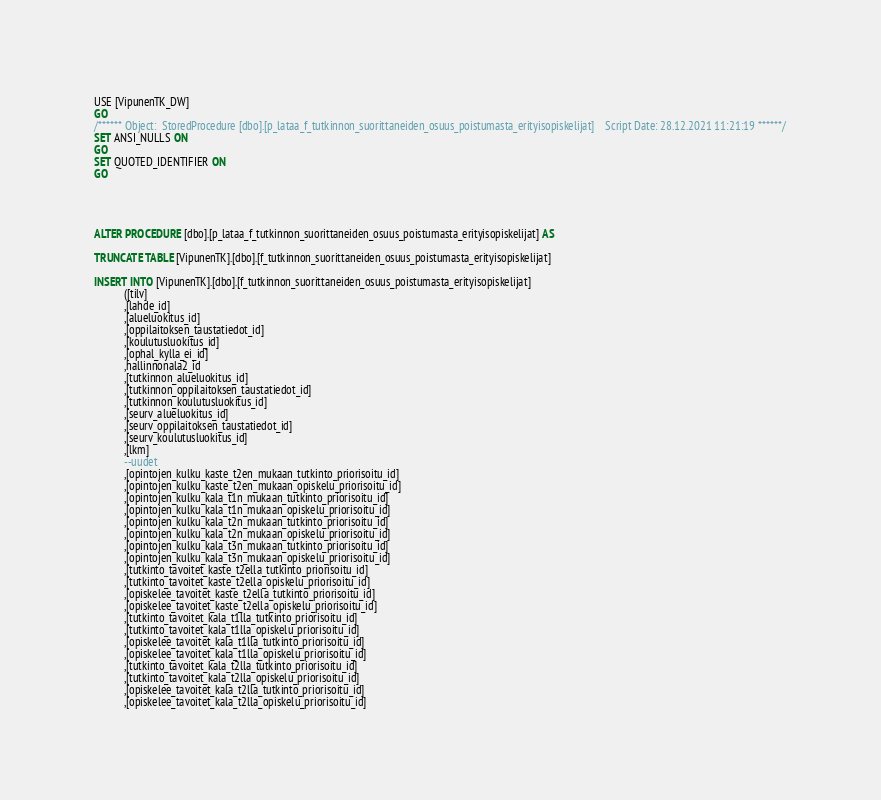<code> <loc_0><loc_0><loc_500><loc_500><_SQL_>USE [VipunenTK_DW]
GO
/****** Object:  StoredProcedure [dbo].[p_lataa_f_tutkinnon_suorittaneiden_osuus_poistumasta_erityisopiskelijat]    Script Date: 28.12.2021 11:21:19 ******/
SET ANSI_NULLS ON
GO
SET QUOTED_IDENTIFIER ON
GO




ALTER PROCEDURE [dbo].[p_lataa_f_tutkinnon_suorittaneiden_osuus_poistumasta_erityisopiskelijat] AS

TRUNCATE TABLE [VipunenTK].[dbo].[f_tutkinnon_suorittaneiden_osuus_poistumasta_erityisopiskelijat]

INSERT INTO [VipunenTK].[dbo].[f_tutkinnon_suorittaneiden_osuus_poistumasta_erityisopiskelijat]
           ([tilv]
           ,[lahde_id]
           ,[alueluokitus_id]
           ,[oppilaitoksen_taustatiedot_id]
           ,[koulutusluokitus_id]
           ,[ophal_kylla_ei_id]
		   ,hallinnonala2_id
           ,[tutkinnon_alueluokitus_id]
           ,[tutkinnon_oppilaitoksen_taustatiedot_id]
           ,[tutkinnon_koulutusluokitus_id]
           ,[seurv_alueluokitus_id]
           ,[seurv_oppilaitoksen_taustatiedot_id]
           ,[seurv_koulutusluokitus_id]
           ,[lkm]
		   --uudet
           ,[opintojen_kulku_kaste_t2en_mukaan_tutkinto_priorisoitu_id]
           ,[opintojen_kulku_kaste_t2en_mukaan_opiskelu_priorisoitu_id]
           ,[opintojen_kulku_kala_t1n_mukaan_tutkinto_priorisoitu_id]
           ,[opintojen_kulku_kala_t1n_mukaan_opiskelu_priorisoitu_id]
           ,[opintojen_kulku_kala_t2n_mukaan_tutkinto_priorisoitu_id]
           ,[opintojen_kulku_kala_t2n_mukaan_opiskelu_priorisoitu_id]
           ,[opintojen_kulku_kala_t3n_mukaan_tutkinto_priorisoitu_id]
           ,[opintojen_kulku_kala_t3n_mukaan_opiskelu_priorisoitu_id]
           ,[tutkinto_tavoitet_kaste_t2ella_tutkinto_priorisoitu_id]
           ,[tutkinto_tavoitet_kaste_t2ella_opiskelu_priorisoitu_id]
           ,[opiskelee_tavoitet_kaste_t2ella_tutkinto_priorisoitu_id]
           ,[opiskelee_tavoitet_kaste_t2ella_opiskelu_priorisoitu_id]
           ,[tutkinto_tavoitet_kala_t1lla_tutkinto_priorisoitu_id]
           ,[tutkinto_tavoitet_kala_t1lla_opiskelu_priorisoitu_id]
           ,[opiskelee_tavoitet_kala_t1lla_tutkinto_priorisoitu_id]
           ,[opiskelee_tavoitet_kala_t1lla_opiskelu_priorisoitu_id]
           ,[tutkinto_tavoitet_kala_t2lla_tutkinto_priorisoitu_id]
           ,[tutkinto_tavoitet_kala_t2lla_opiskelu_priorisoitu_id]
           ,[opiskelee_tavoitet_kala_t2lla_tutkinto_priorisoitu_id]
           ,[opiskelee_tavoitet_kala_t2lla_opiskelu_priorisoitu_id]</code> 